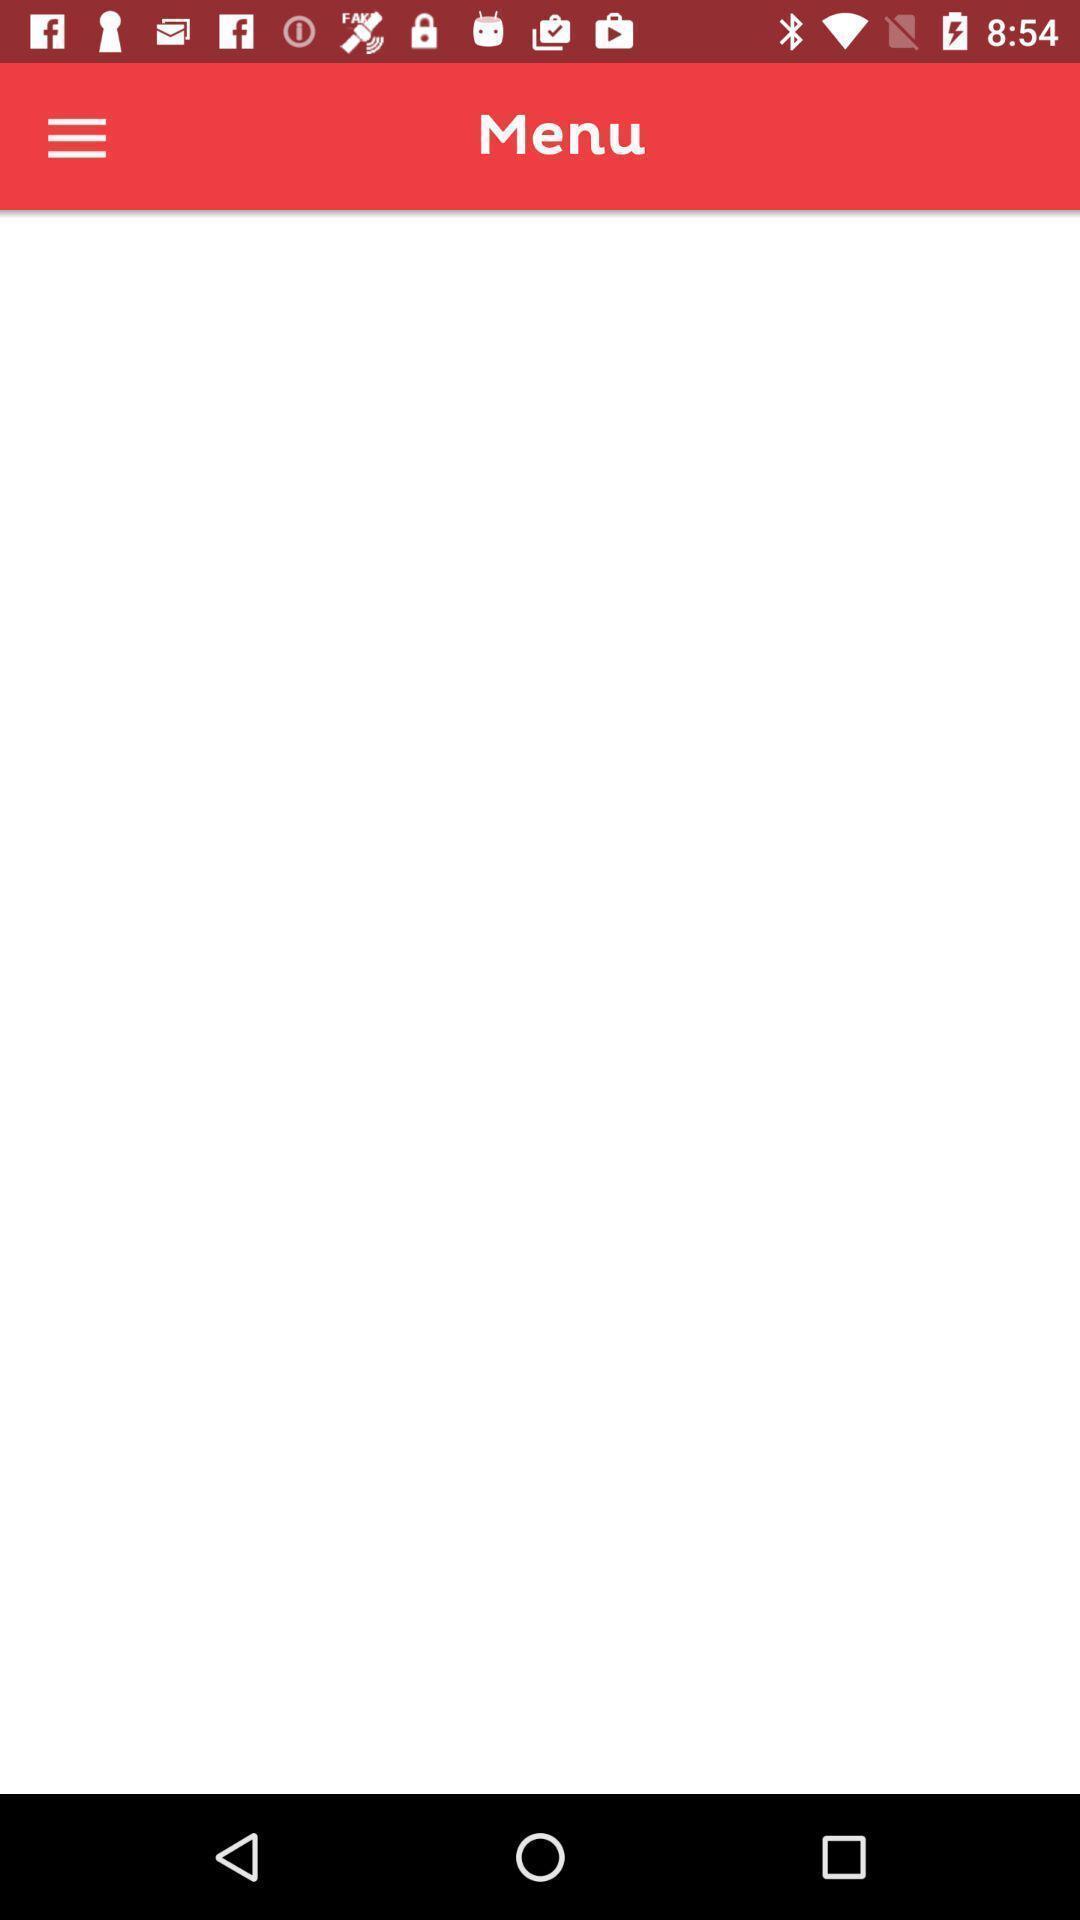Tell me about the visual elements in this screen capture. Screen displaying menu page. 